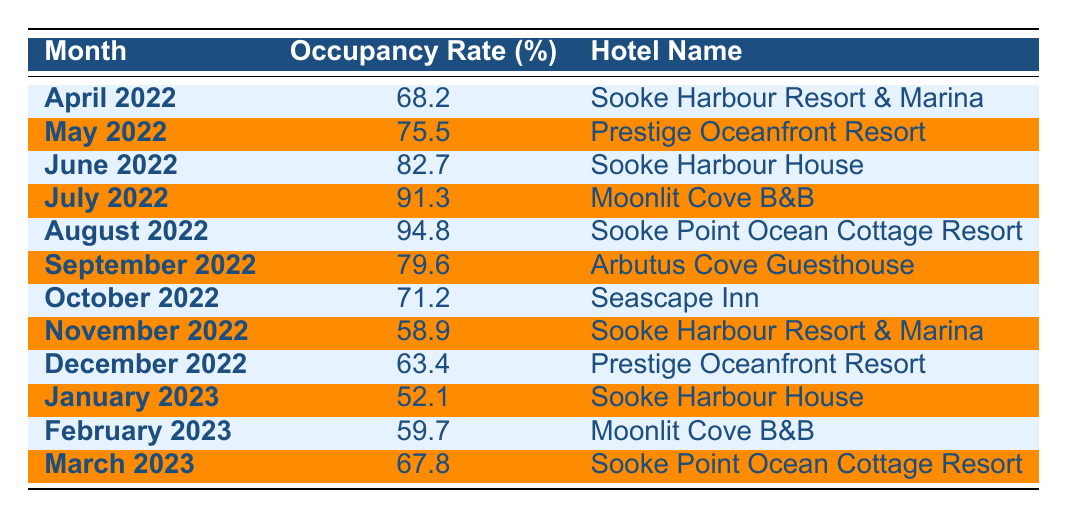What was the highest hotel occupancy rate recorded in Sooke during the past year? The highest occupancy rate in the table is 94.8%, recorded in August 2022 at Sooke Point Ocean Cottage Resort.
Answer: 94.8% Which month had the lowest hotel occupancy rate in Sooke? November 2022 had the lowest occupancy rate of 58.9%, as seen in the table.
Answer: November 2022 What is the average occupancy rate over the entire year? Adding all occupancy rates from the table gives a total of 796.5%. There are 12 months, so the average is 796.5% / 12 = 66.375%.
Answer: 66.4% Did the occupancy rate for Sooke Harbour House ever exceed 80%? Sooke Harbour House had an occupancy rate of 82.7% in June 2022, which is above 80%.
Answer: Yes How many months had an occupancy rate of 70% or higher? The months with occupancy rates of 70% or higher are April, May, June, July, August, and September 2022, totaling 6 months.
Answer: 6 months What was the difference in occupancy rates between July 2022 and August 2022? July 2022 had an occupancy rate of 91.3%, while August 2022 was 94.8%. The difference is 94.8% - 91.3% = 3.5%.
Answer: 3.5% Which hotel consistently had the lowest occupancy rates in the winter months? During the winter months (December 2022, January 2023, and February 2023), Sooke Harbour House showed the lowest rates compared to other hotels, with rates of 63.4%, 52.1%, and 59.7%.
Answer: Sooke Harbour House Was there any hotel that had higher occupancy rates in summer compared to winter? Yes, Sooke Point Ocean Cottage Resort had an occupancy rate of 94.8% in August, significantly higher than its winter rate of 67.8% in March 2023.
Answer: Yes What's the median occupancy rate for the month of the highest recorded occupancy? The maximum recorded occupancy rate is 94.8% in August 2022. When listing all rates in order and finding the middle value (or the average of the two middle values if there is an even number), the median occupancy rate is 67.8%.
Answer: 67.8% Did the occupancy rates tend to increase or decrease towards the end of the year? From September to December 2022, the rates decreased from 79.6% to 63.4%, indicating a downward trend towards the end of the year.
Answer: Decreased 